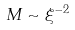Convert formula to latex. <formula><loc_0><loc_0><loc_500><loc_500>M \sim \xi ^ { - 2 }</formula> 